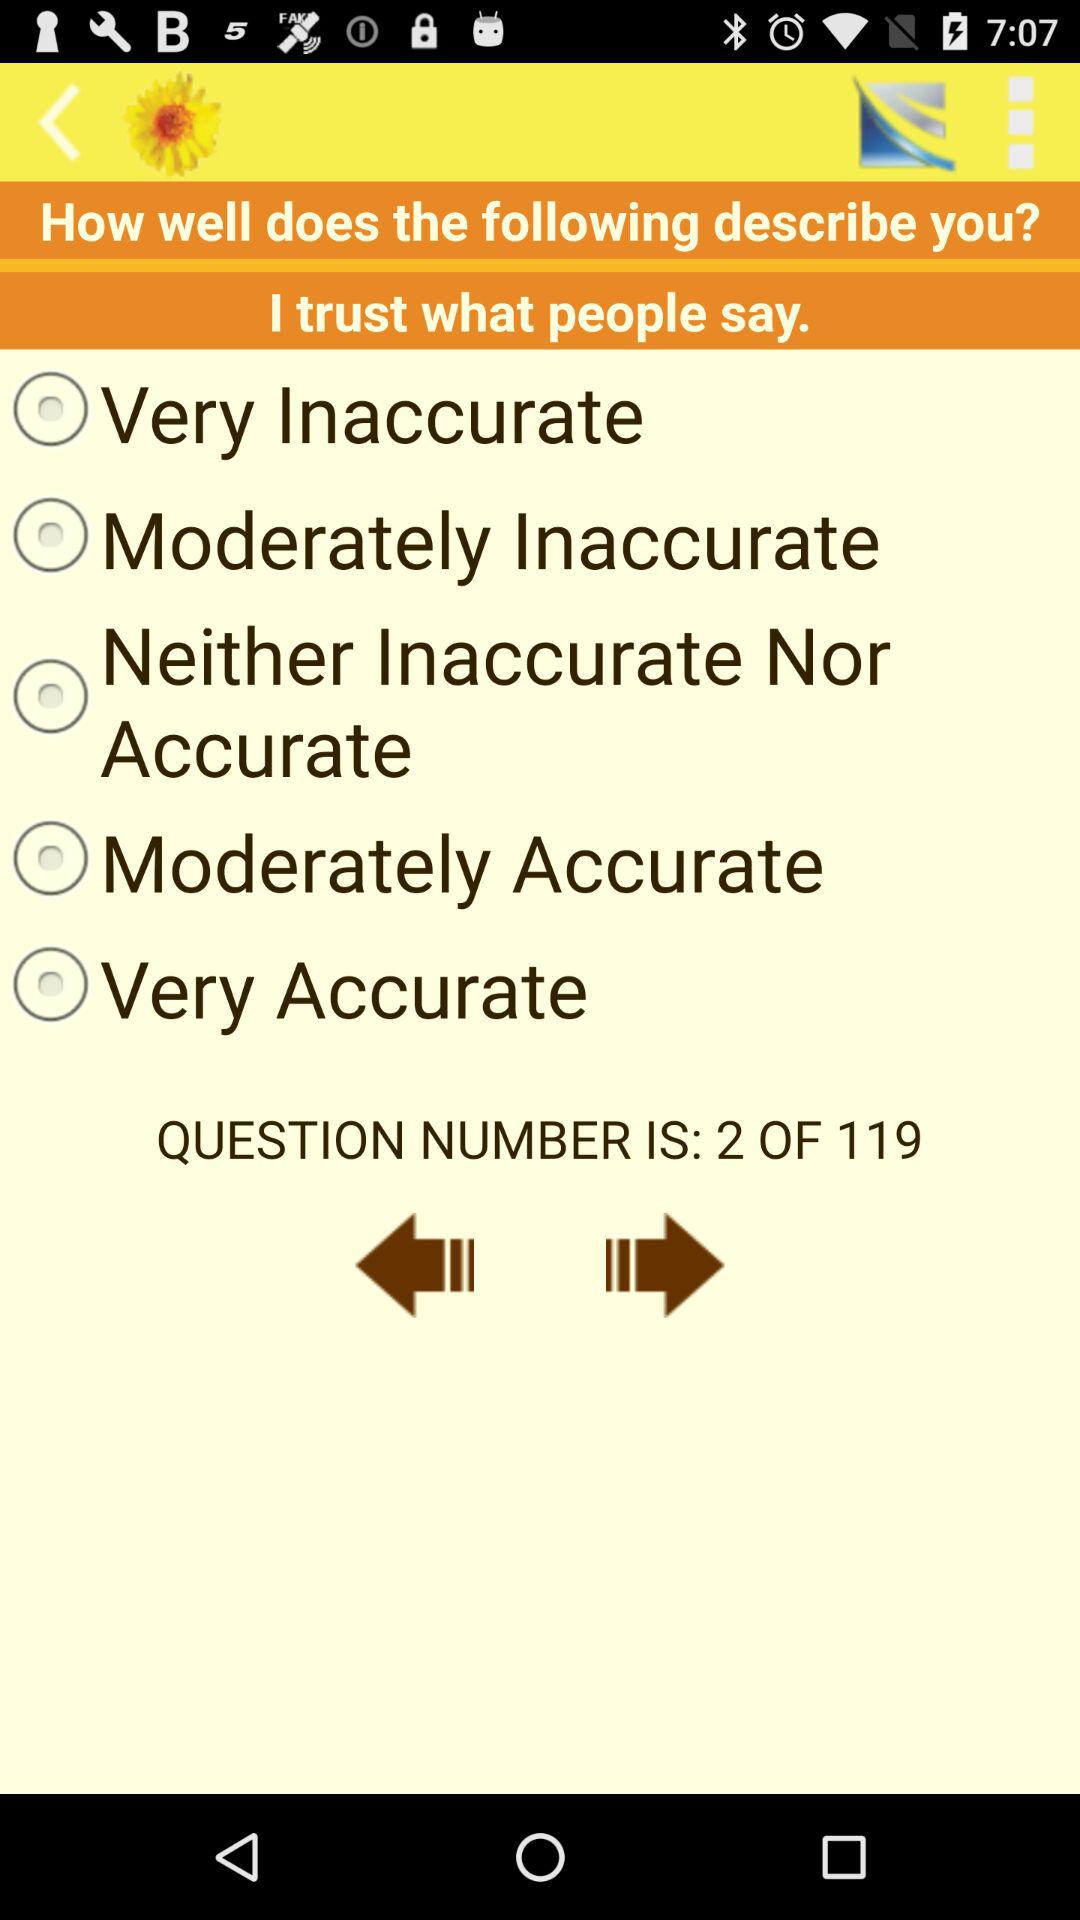What is the total number of questions? The total number of questions is 119. 